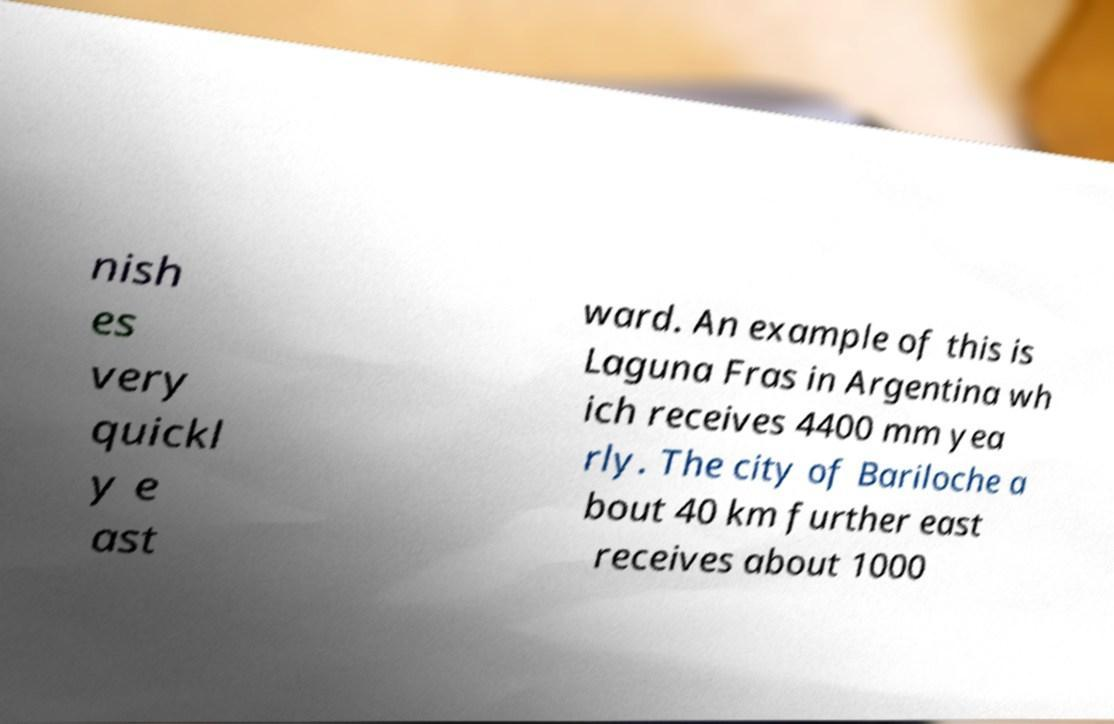Can you accurately transcribe the text from the provided image for me? nish es very quickl y e ast ward. An example of this is Laguna Fras in Argentina wh ich receives 4400 mm yea rly. The city of Bariloche a bout 40 km further east receives about 1000 